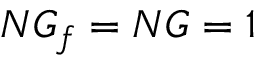<formula> <loc_0><loc_0><loc_500><loc_500>N G _ { f } = N G = 1</formula> 